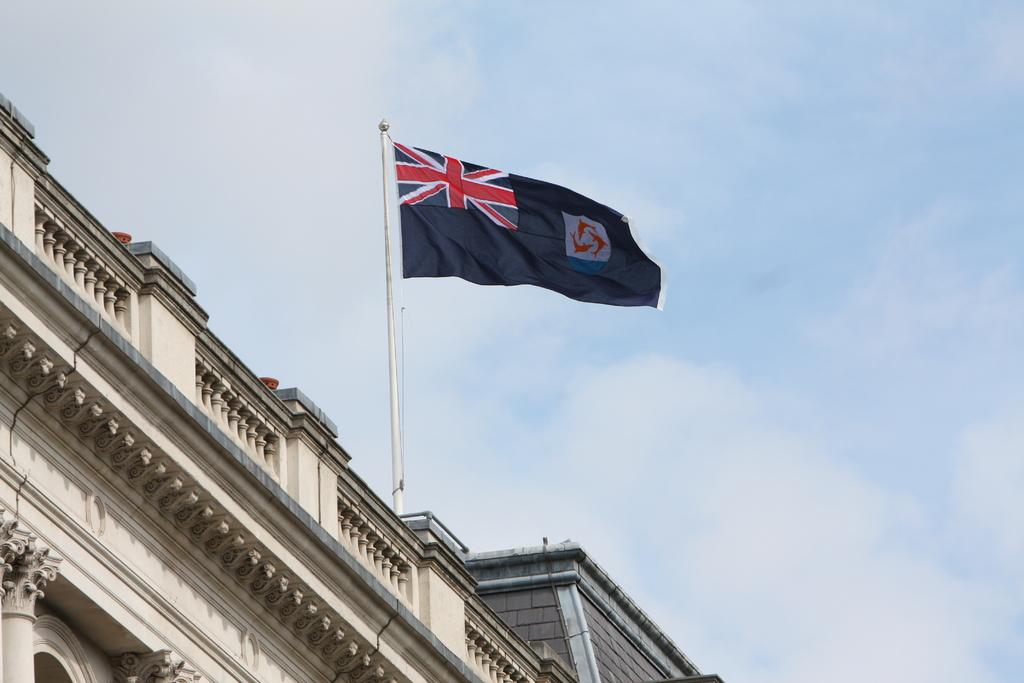What structure is the main subject of the image? There is a building in the image. What is on top of the building? There is a flag on top of the building. How is the flag attached to the building? The flag is attached to a pole. What can be seen in the sky in the image? Clouds are present in the sky. What type of game is being played on the roof of the building in the image? There is no game being played on the roof of the building in the image; it only shows a flag attached to a pole. Is there any poison visible in the image? There is no poison present in the image. 